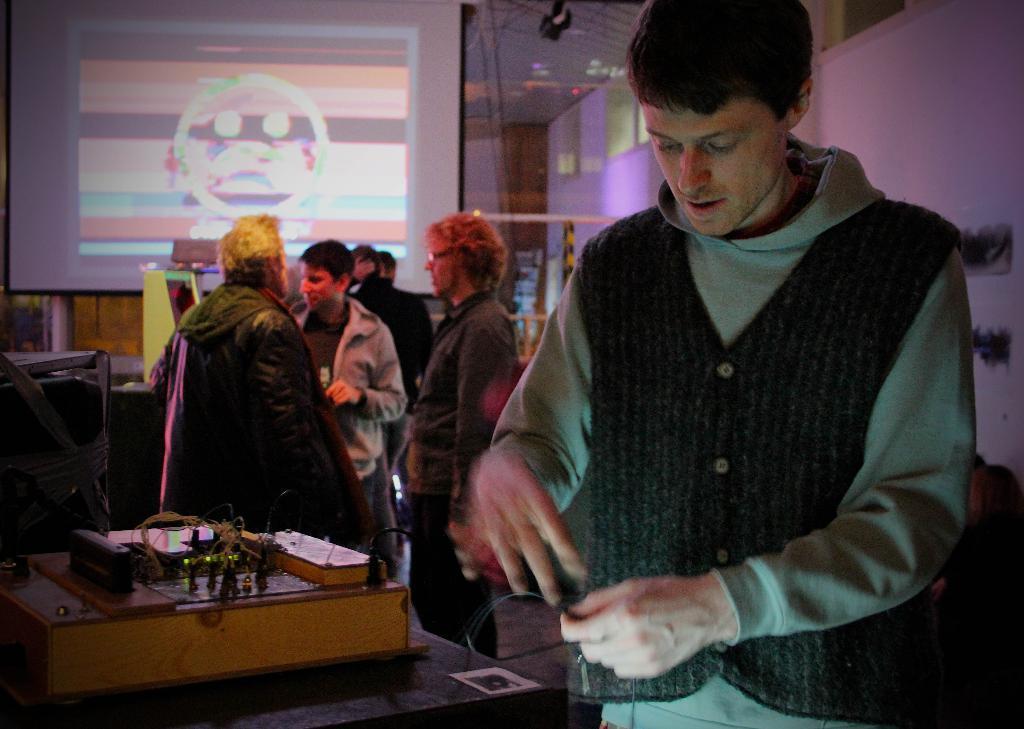Can you describe this image briefly? In this image I can see few people are standing and I can see most of them are wearing jacket. Here I can see one of them is wearing specs. I can also see projector screen in background. 